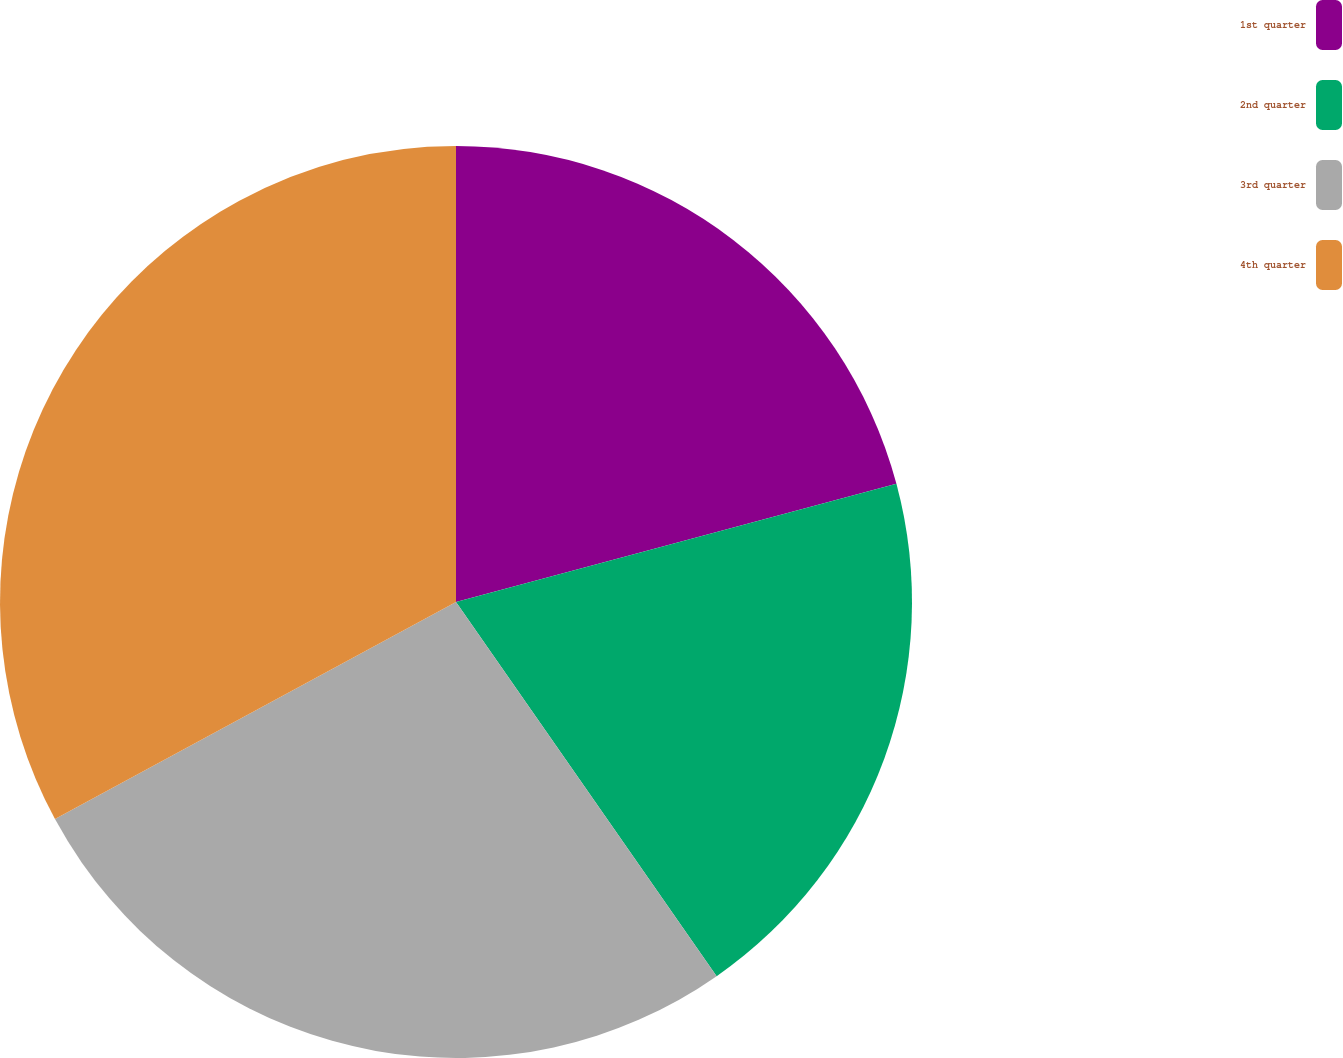Convert chart. <chart><loc_0><loc_0><loc_500><loc_500><pie_chart><fcel>1st quarter<fcel>2nd quarter<fcel>3rd quarter<fcel>4th quarter<nl><fcel>20.83%<fcel>19.49%<fcel>26.79%<fcel>32.9%<nl></chart> 